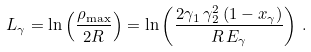Convert formula to latex. <formula><loc_0><loc_0><loc_500><loc_500>L _ { \gamma } = \ln \left ( { \frac { \rho _ { \max } } { 2 R } } \right ) = \ln \left ( \frac { 2 \gamma _ { 1 } \, \gamma ^ { 2 } _ { 2 } \, ( 1 - x _ { \gamma } ) } { R \, E _ { \gamma } } \right ) \, .</formula> 